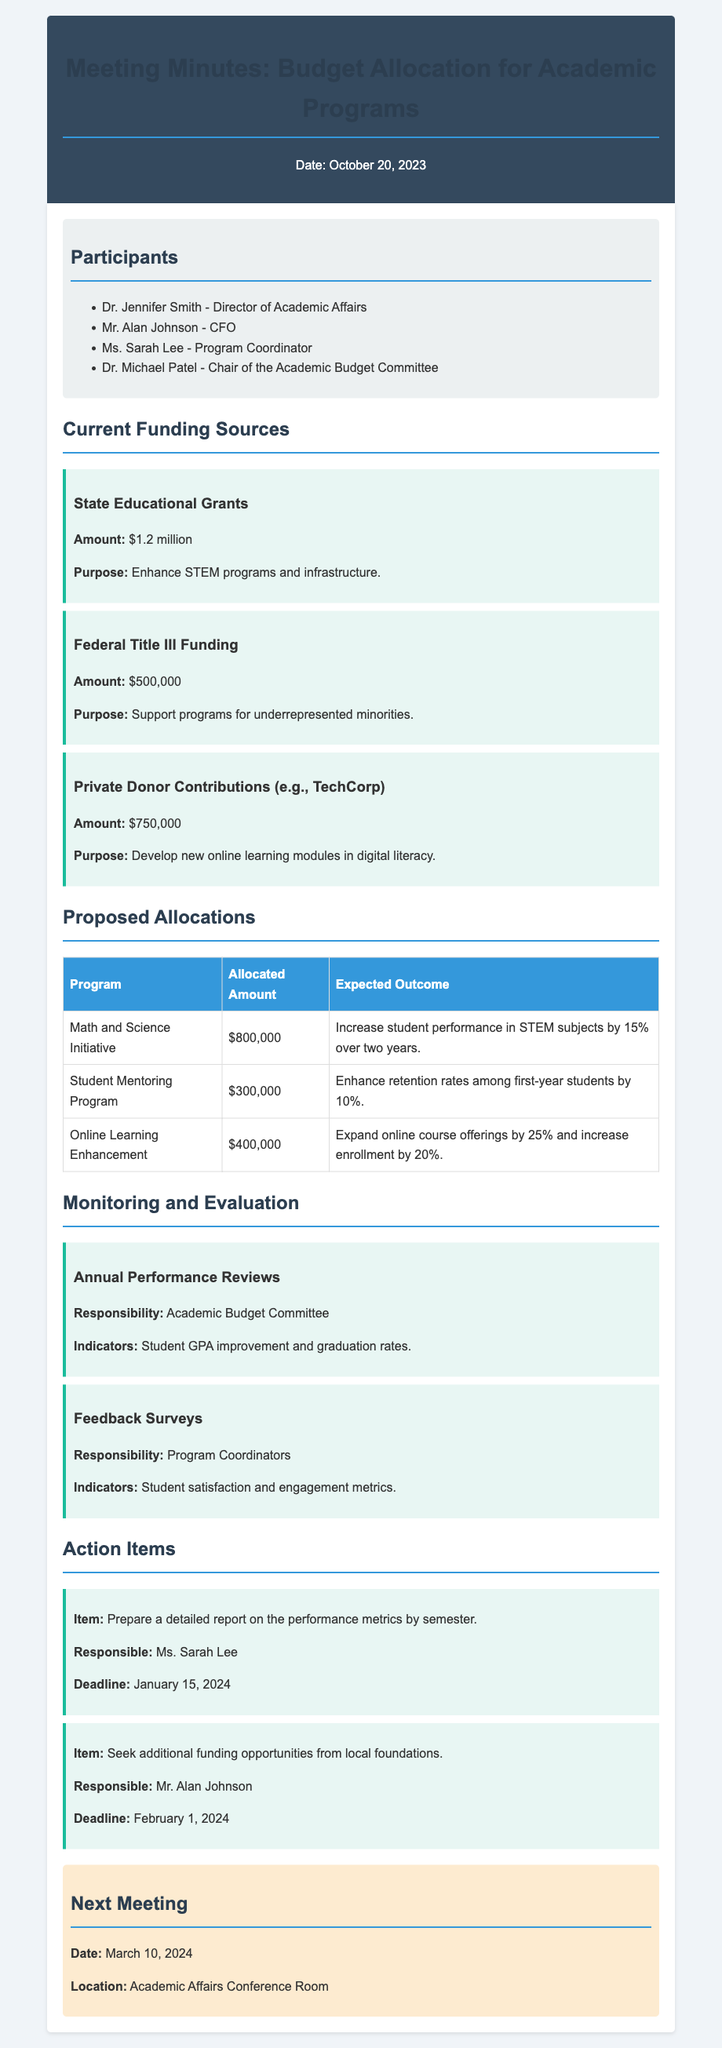What is the total amount of State Educational Grants? The total amount for State Educational Grants is explicitly stated in the funding sources section of the document.
Answer: $1.2 million Who is responsible for the feedback surveys? The responsibility for the feedback surveys is mentioned under the Monitoring and Evaluation section.
Answer: Program Coordinators What is the purpose of Federal Title III Funding? The purpose is stated clearly under the current funding sources section of the document.
Answer: Support programs for underrepresented minorities What is the expected outcome of the Math and Science Initiative? The expected outcome is detailed in the Proposed Allocations table.
Answer: Increase student performance in STEM subjects by 15% over two years When is the next meeting scheduled? The date for the next meeting is provided in the Next Meeting section of the document.
Answer: March 10, 2024 How much funding is allocated for the Student Mentoring Program? The allocated amount is listed in the Proposed Allocations table.
Answer: $300,000 What was the primary focus of the budget meeting? The focus of the meeting is derived from the title and introduction presented in the document.
Answer: Budget allocation for academic programs What is the deadline for preparing the detailed report on performance metrics? The deadline is stated in the action item section.
Answer: January 15, 2024 